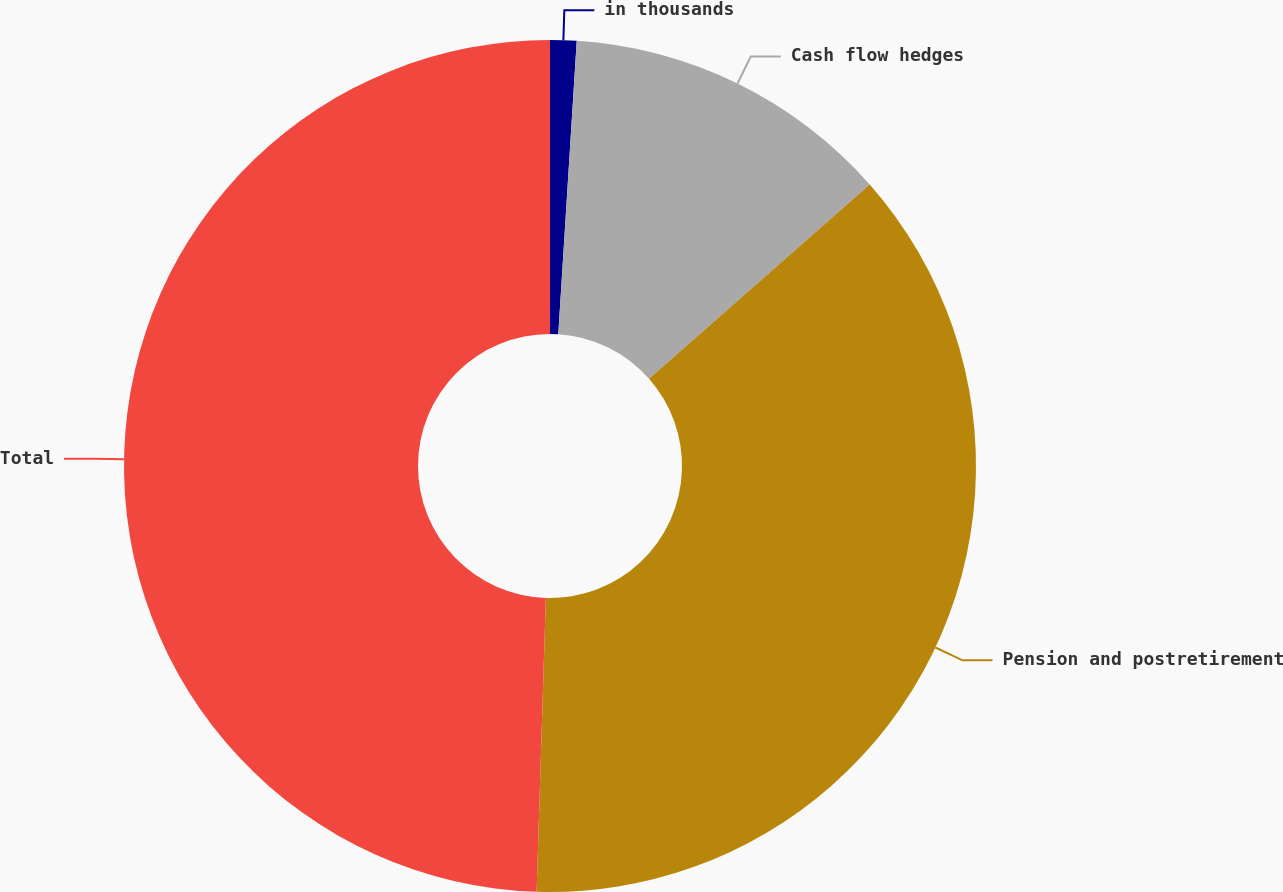Convert chart to OTSL. <chart><loc_0><loc_0><loc_500><loc_500><pie_chart><fcel>in thousands<fcel>Cash flow hedges<fcel>Pension and postretirement<fcel>Total<nl><fcel>1.0%<fcel>12.51%<fcel>36.99%<fcel>49.5%<nl></chart> 